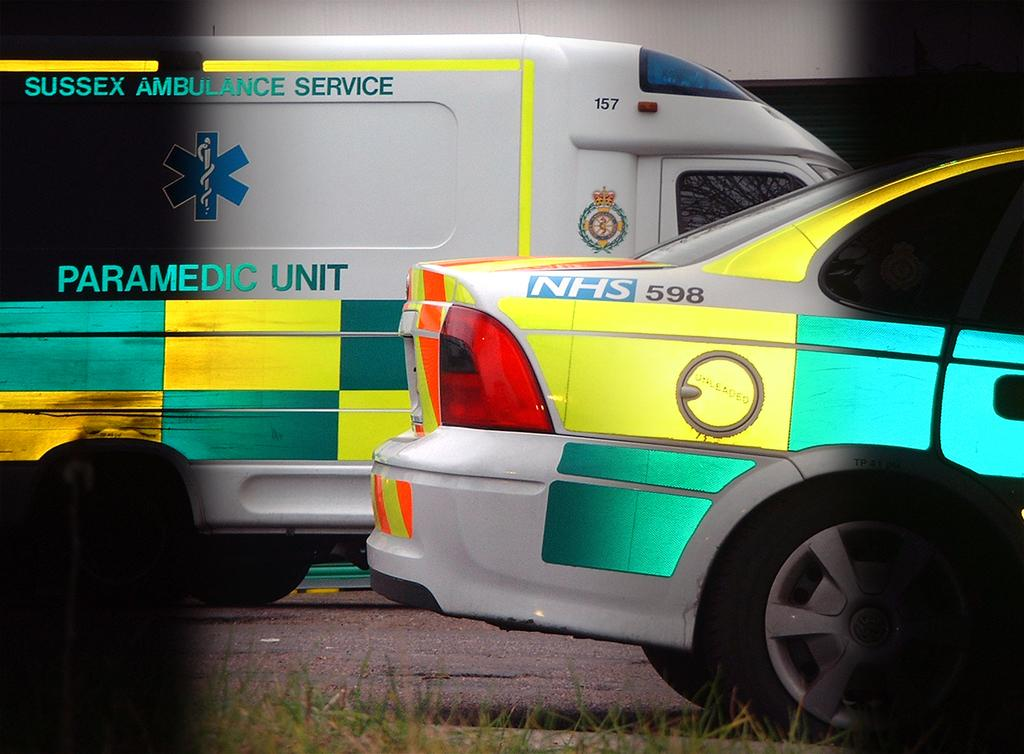<image>
Summarize the visual content of the image. A white van says Paramedic Unit and has green and yellow checkers. 